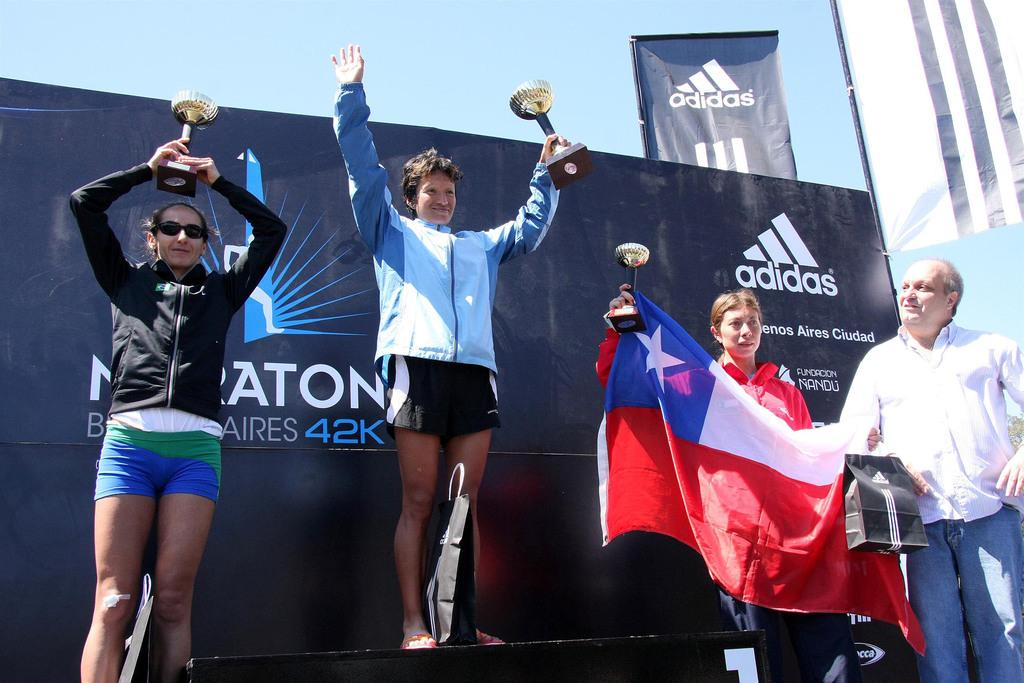<image>
Render a clear and concise summary of the photo. Several sports people in front of a backdrop which advertises Adidas. 